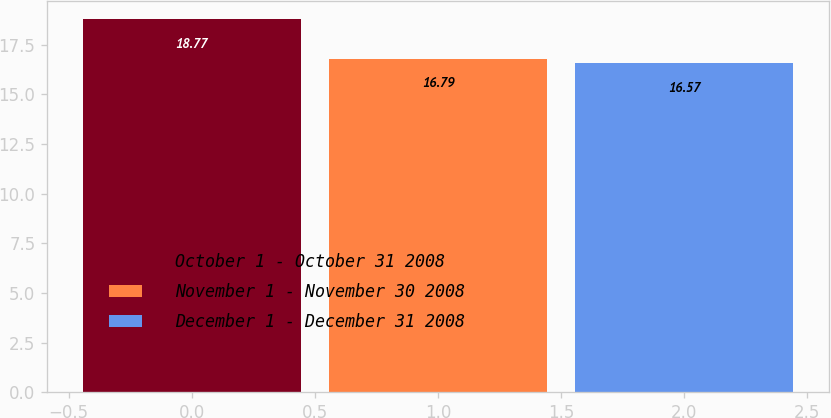Convert chart to OTSL. <chart><loc_0><loc_0><loc_500><loc_500><bar_chart><fcel>October 1 - October 31 2008<fcel>November 1 - November 30 2008<fcel>December 1 - December 31 2008<nl><fcel>18.77<fcel>16.79<fcel>16.57<nl></chart> 